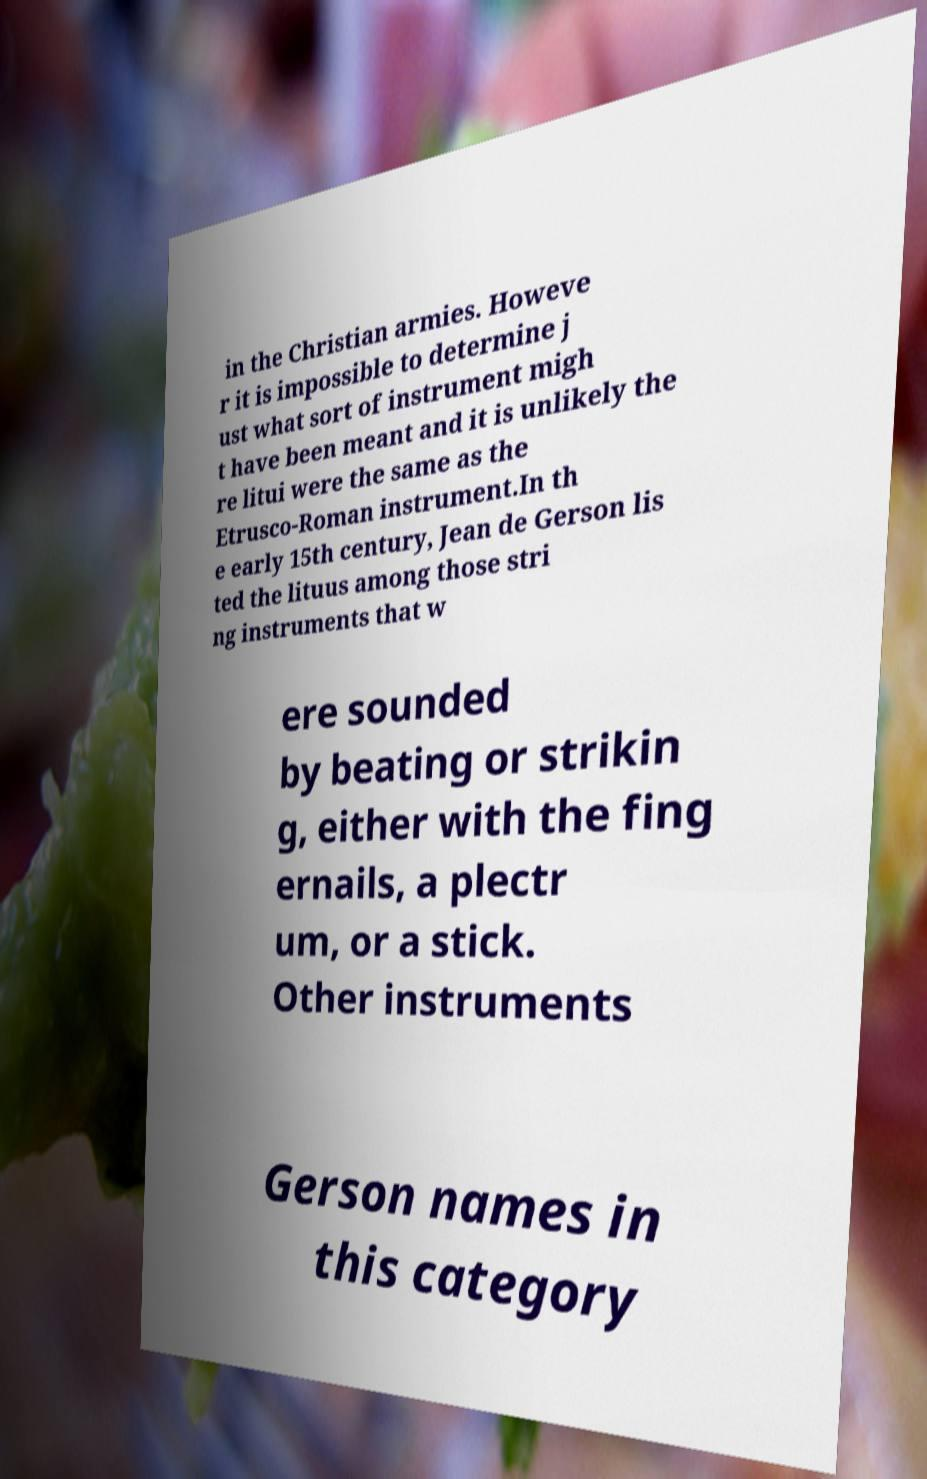Can you accurately transcribe the text from the provided image for me? in the Christian armies. Howeve r it is impossible to determine j ust what sort of instrument migh t have been meant and it is unlikely the re litui were the same as the Etrusco-Roman instrument.In th e early 15th century, Jean de Gerson lis ted the lituus among those stri ng instruments that w ere sounded by beating or strikin g, either with the fing ernails, a plectr um, or a stick. Other instruments Gerson names in this category 